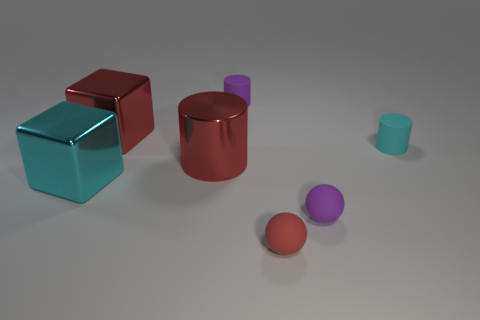Add 2 purple matte cylinders. How many objects exist? 9 Subtract all blocks. How many objects are left? 5 Add 6 cyan shiny cubes. How many cyan shiny cubes exist? 7 Subtract 0 brown cylinders. How many objects are left? 7 Subtract all large objects. Subtract all red metallic cubes. How many objects are left? 3 Add 5 small red rubber things. How many small red rubber things are left? 6 